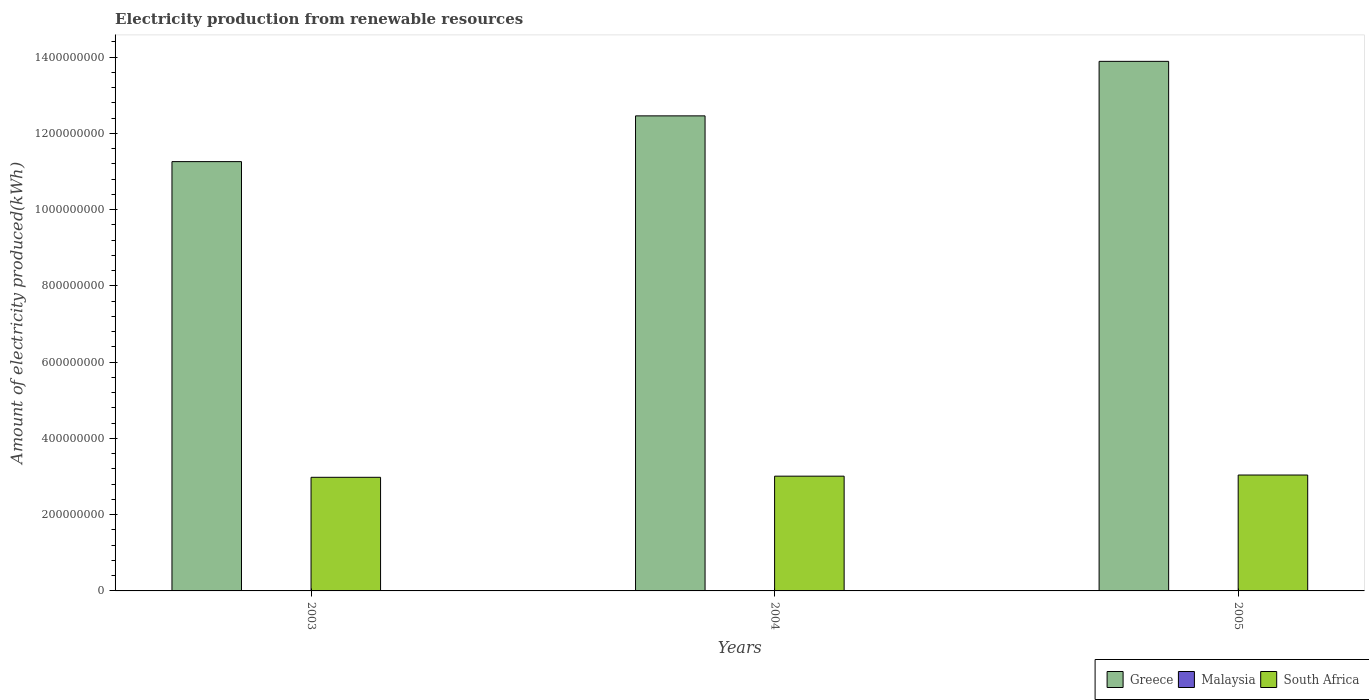How many different coloured bars are there?
Provide a short and direct response. 3. Are the number of bars on each tick of the X-axis equal?
Your answer should be compact. Yes. How many bars are there on the 1st tick from the left?
Make the answer very short. 3. How many bars are there on the 1st tick from the right?
Make the answer very short. 3. What is the amount of electricity produced in Greece in 2005?
Ensure brevity in your answer.  1.39e+09. Across all years, what is the maximum amount of electricity produced in Malaysia?
Your answer should be very brief. 1.00e+06. Across all years, what is the minimum amount of electricity produced in Greece?
Provide a succinct answer. 1.13e+09. In which year was the amount of electricity produced in South Africa maximum?
Make the answer very short. 2005. In which year was the amount of electricity produced in Malaysia minimum?
Offer a terse response. 2003. What is the difference between the amount of electricity produced in South Africa in 2003 and that in 2004?
Your response must be concise. -3.00e+06. What is the difference between the amount of electricity produced in Greece in 2005 and the amount of electricity produced in Malaysia in 2004?
Ensure brevity in your answer.  1.39e+09. In the year 2003, what is the difference between the amount of electricity produced in South Africa and amount of electricity produced in Greece?
Give a very brief answer. -8.28e+08. What is the ratio of the amount of electricity produced in Greece in 2003 to that in 2004?
Make the answer very short. 0.9. Is the amount of electricity produced in Greece in 2004 less than that in 2005?
Provide a short and direct response. Yes. Is the difference between the amount of electricity produced in South Africa in 2003 and 2004 greater than the difference between the amount of electricity produced in Greece in 2003 and 2004?
Make the answer very short. Yes. What is the difference between the highest and the second highest amount of electricity produced in Greece?
Give a very brief answer. 1.43e+08. What is the difference between the highest and the lowest amount of electricity produced in Greece?
Your answer should be compact. 2.63e+08. What does the 3rd bar from the left in 2005 represents?
Ensure brevity in your answer.  South Africa. What does the 1st bar from the right in 2003 represents?
Offer a terse response. South Africa. Are all the bars in the graph horizontal?
Your answer should be very brief. No. Are the values on the major ticks of Y-axis written in scientific E-notation?
Ensure brevity in your answer.  No. Does the graph contain grids?
Offer a terse response. No. What is the title of the graph?
Provide a short and direct response. Electricity production from renewable resources. What is the label or title of the X-axis?
Provide a short and direct response. Years. What is the label or title of the Y-axis?
Offer a terse response. Amount of electricity produced(kWh). What is the Amount of electricity produced(kWh) in Greece in 2003?
Offer a terse response. 1.13e+09. What is the Amount of electricity produced(kWh) in South Africa in 2003?
Your answer should be compact. 2.98e+08. What is the Amount of electricity produced(kWh) in Greece in 2004?
Give a very brief answer. 1.25e+09. What is the Amount of electricity produced(kWh) in South Africa in 2004?
Your answer should be very brief. 3.01e+08. What is the Amount of electricity produced(kWh) of Greece in 2005?
Offer a terse response. 1.39e+09. What is the Amount of electricity produced(kWh) of South Africa in 2005?
Make the answer very short. 3.04e+08. Across all years, what is the maximum Amount of electricity produced(kWh) of Greece?
Offer a very short reply. 1.39e+09. Across all years, what is the maximum Amount of electricity produced(kWh) of Malaysia?
Give a very brief answer. 1.00e+06. Across all years, what is the maximum Amount of electricity produced(kWh) in South Africa?
Make the answer very short. 3.04e+08. Across all years, what is the minimum Amount of electricity produced(kWh) in Greece?
Your answer should be compact. 1.13e+09. Across all years, what is the minimum Amount of electricity produced(kWh) of Malaysia?
Your answer should be compact. 1.00e+06. Across all years, what is the minimum Amount of electricity produced(kWh) in South Africa?
Provide a short and direct response. 2.98e+08. What is the total Amount of electricity produced(kWh) of Greece in the graph?
Provide a succinct answer. 3.76e+09. What is the total Amount of electricity produced(kWh) of Malaysia in the graph?
Provide a short and direct response. 3.00e+06. What is the total Amount of electricity produced(kWh) of South Africa in the graph?
Keep it short and to the point. 9.03e+08. What is the difference between the Amount of electricity produced(kWh) in Greece in 2003 and that in 2004?
Give a very brief answer. -1.20e+08. What is the difference between the Amount of electricity produced(kWh) in Malaysia in 2003 and that in 2004?
Make the answer very short. 0. What is the difference between the Amount of electricity produced(kWh) of Greece in 2003 and that in 2005?
Offer a very short reply. -2.63e+08. What is the difference between the Amount of electricity produced(kWh) in Malaysia in 2003 and that in 2005?
Provide a succinct answer. 0. What is the difference between the Amount of electricity produced(kWh) in South Africa in 2003 and that in 2005?
Your response must be concise. -6.00e+06. What is the difference between the Amount of electricity produced(kWh) in Greece in 2004 and that in 2005?
Offer a terse response. -1.43e+08. What is the difference between the Amount of electricity produced(kWh) of Malaysia in 2004 and that in 2005?
Provide a succinct answer. 0. What is the difference between the Amount of electricity produced(kWh) in South Africa in 2004 and that in 2005?
Provide a short and direct response. -3.00e+06. What is the difference between the Amount of electricity produced(kWh) in Greece in 2003 and the Amount of electricity produced(kWh) in Malaysia in 2004?
Provide a succinct answer. 1.12e+09. What is the difference between the Amount of electricity produced(kWh) in Greece in 2003 and the Amount of electricity produced(kWh) in South Africa in 2004?
Make the answer very short. 8.25e+08. What is the difference between the Amount of electricity produced(kWh) of Malaysia in 2003 and the Amount of electricity produced(kWh) of South Africa in 2004?
Make the answer very short. -3.00e+08. What is the difference between the Amount of electricity produced(kWh) in Greece in 2003 and the Amount of electricity produced(kWh) in Malaysia in 2005?
Keep it short and to the point. 1.12e+09. What is the difference between the Amount of electricity produced(kWh) in Greece in 2003 and the Amount of electricity produced(kWh) in South Africa in 2005?
Make the answer very short. 8.22e+08. What is the difference between the Amount of electricity produced(kWh) in Malaysia in 2003 and the Amount of electricity produced(kWh) in South Africa in 2005?
Provide a succinct answer. -3.03e+08. What is the difference between the Amount of electricity produced(kWh) of Greece in 2004 and the Amount of electricity produced(kWh) of Malaysia in 2005?
Offer a very short reply. 1.24e+09. What is the difference between the Amount of electricity produced(kWh) in Greece in 2004 and the Amount of electricity produced(kWh) in South Africa in 2005?
Provide a short and direct response. 9.42e+08. What is the difference between the Amount of electricity produced(kWh) in Malaysia in 2004 and the Amount of electricity produced(kWh) in South Africa in 2005?
Your answer should be very brief. -3.03e+08. What is the average Amount of electricity produced(kWh) in Greece per year?
Provide a succinct answer. 1.25e+09. What is the average Amount of electricity produced(kWh) of South Africa per year?
Provide a succinct answer. 3.01e+08. In the year 2003, what is the difference between the Amount of electricity produced(kWh) of Greece and Amount of electricity produced(kWh) of Malaysia?
Offer a very short reply. 1.12e+09. In the year 2003, what is the difference between the Amount of electricity produced(kWh) of Greece and Amount of electricity produced(kWh) of South Africa?
Offer a very short reply. 8.28e+08. In the year 2003, what is the difference between the Amount of electricity produced(kWh) of Malaysia and Amount of electricity produced(kWh) of South Africa?
Give a very brief answer. -2.97e+08. In the year 2004, what is the difference between the Amount of electricity produced(kWh) of Greece and Amount of electricity produced(kWh) of Malaysia?
Make the answer very short. 1.24e+09. In the year 2004, what is the difference between the Amount of electricity produced(kWh) of Greece and Amount of electricity produced(kWh) of South Africa?
Offer a very short reply. 9.45e+08. In the year 2004, what is the difference between the Amount of electricity produced(kWh) of Malaysia and Amount of electricity produced(kWh) of South Africa?
Your answer should be compact. -3.00e+08. In the year 2005, what is the difference between the Amount of electricity produced(kWh) of Greece and Amount of electricity produced(kWh) of Malaysia?
Ensure brevity in your answer.  1.39e+09. In the year 2005, what is the difference between the Amount of electricity produced(kWh) in Greece and Amount of electricity produced(kWh) in South Africa?
Your answer should be compact. 1.08e+09. In the year 2005, what is the difference between the Amount of electricity produced(kWh) of Malaysia and Amount of electricity produced(kWh) of South Africa?
Make the answer very short. -3.03e+08. What is the ratio of the Amount of electricity produced(kWh) of Greece in 2003 to that in 2004?
Make the answer very short. 0.9. What is the ratio of the Amount of electricity produced(kWh) in Greece in 2003 to that in 2005?
Make the answer very short. 0.81. What is the ratio of the Amount of electricity produced(kWh) of South Africa in 2003 to that in 2005?
Your answer should be compact. 0.98. What is the ratio of the Amount of electricity produced(kWh) in Greece in 2004 to that in 2005?
Provide a succinct answer. 0.9. What is the ratio of the Amount of electricity produced(kWh) of South Africa in 2004 to that in 2005?
Your answer should be compact. 0.99. What is the difference between the highest and the second highest Amount of electricity produced(kWh) of Greece?
Your answer should be compact. 1.43e+08. What is the difference between the highest and the second highest Amount of electricity produced(kWh) in Malaysia?
Your answer should be very brief. 0. What is the difference between the highest and the second highest Amount of electricity produced(kWh) of South Africa?
Offer a terse response. 3.00e+06. What is the difference between the highest and the lowest Amount of electricity produced(kWh) in Greece?
Provide a short and direct response. 2.63e+08. What is the difference between the highest and the lowest Amount of electricity produced(kWh) of Malaysia?
Your answer should be compact. 0. What is the difference between the highest and the lowest Amount of electricity produced(kWh) of South Africa?
Your answer should be compact. 6.00e+06. 